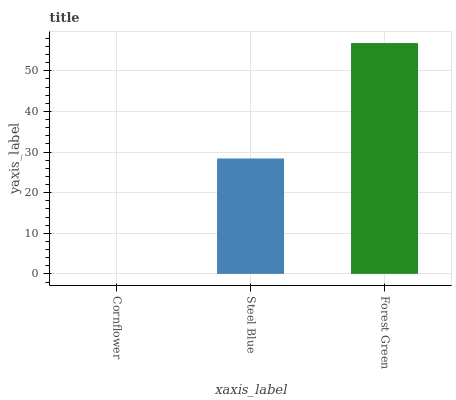Is Steel Blue the minimum?
Answer yes or no. No. Is Steel Blue the maximum?
Answer yes or no. No. Is Steel Blue greater than Cornflower?
Answer yes or no. Yes. Is Cornflower less than Steel Blue?
Answer yes or no. Yes. Is Cornflower greater than Steel Blue?
Answer yes or no. No. Is Steel Blue less than Cornflower?
Answer yes or no. No. Is Steel Blue the high median?
Answer yes or no. Yes. Is Steel Blue the low median?
Answer yes or no. Yes. Is Forest Green the high median?
Answer yes or no. No. Is Forest Green the low median?
Answer yes or no. No. 